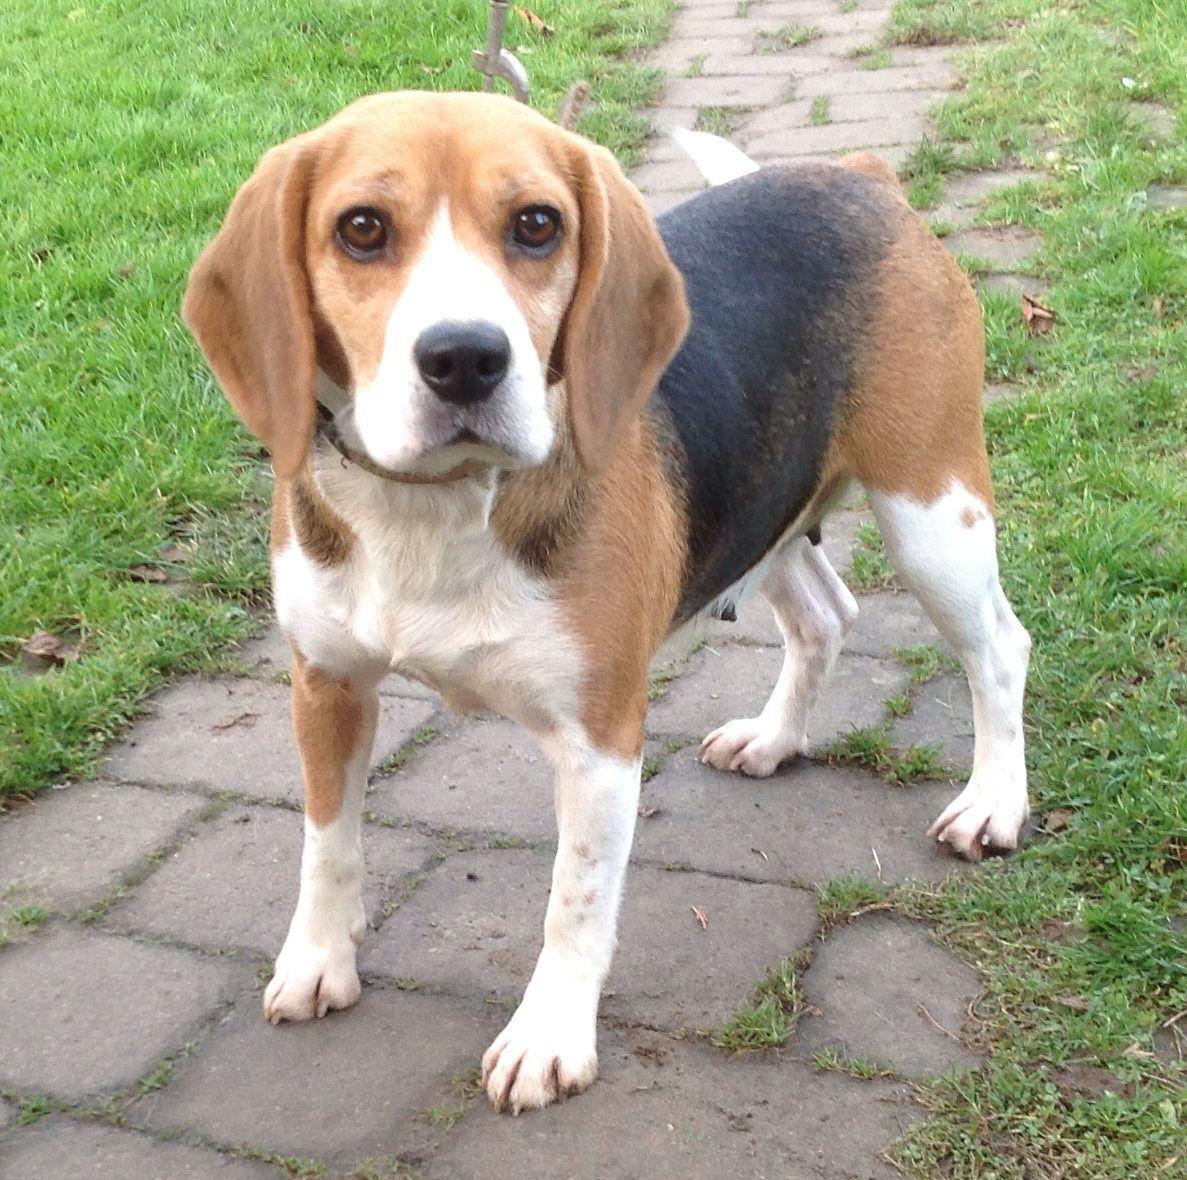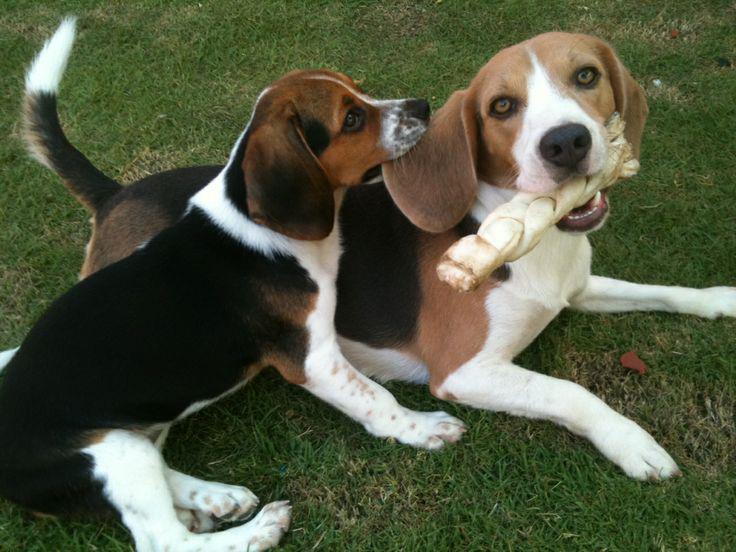The first image is the image on the left, the second image is the image on the right. Examine the images to the left and right. Is the description "An image shows beagle dogs behind a horizontal wood plank rail." accurate? Answer yes or no. No. 